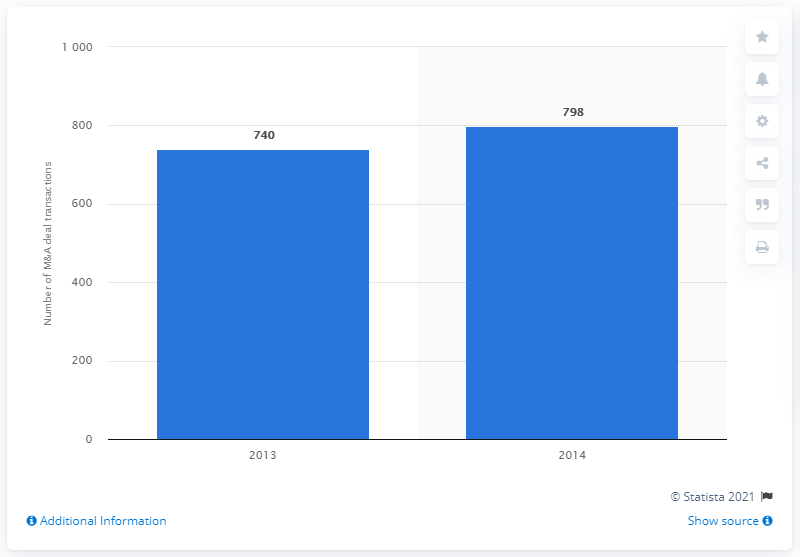Give some essential details in this illustration. In 2013, the number of deals reached was 740. In 2014, the deal count was 798. 